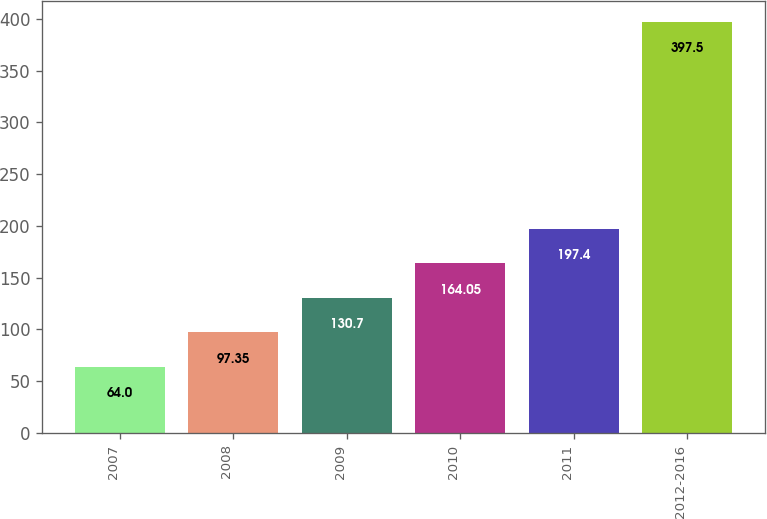Convert chart. <chart><loc_0><loc_0><loc_500><loc_500><bar_chart><fcel>2007<fcel>2008<fcel>2009<fcel>2010<fcel>2011<fcel>2012-2016<nl><fcel>64<fcel>97.35<fcel>130.7<fcel>164.05<fcel>197.4<fcel>397.5<nl></chart> 